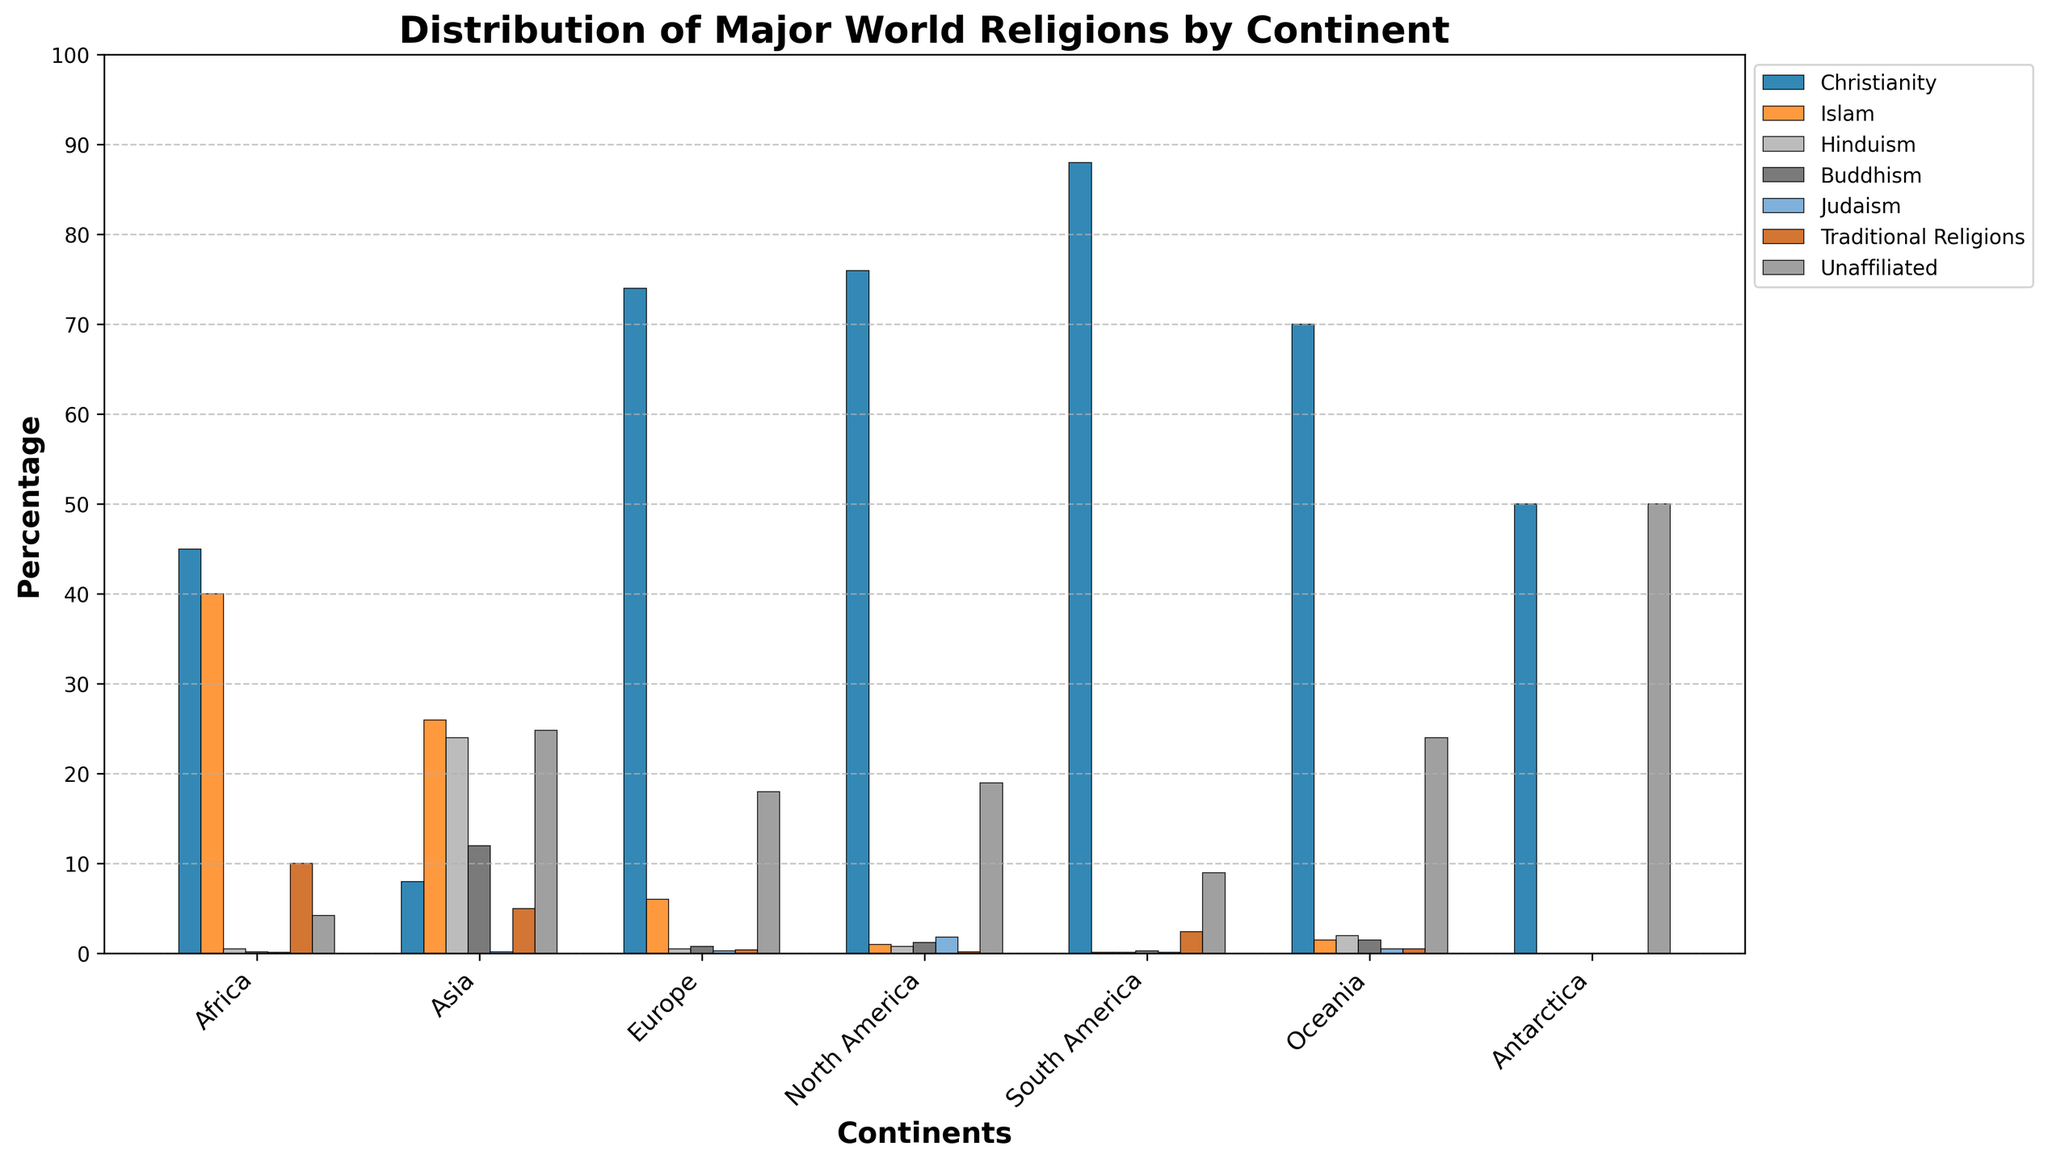What continent has the highest percentage of Christianity? Observing the bar heights for Christianity, the highest bar is over South America.
Answer: South America Which continent has an equal percentage of Unaffiliated and Christianity? By comparing the bars for each religion and continent, Antarctica has equal bars for Unaffiliated and Christianity.
Answer: Antarctica How does the percentage of Islam in Africa compare to that in Asia? The bar for Islam in Africa is at 40, while in Asia it is at 26.
Answer: Higher in Africa Which continent shows the least proportion of Judaism? Observing the bars for Judaism, most continents have some level, but Africa, Asia, and South America each have bars at 0.1 or lower, with South America specifically having the least proportion at 0.1.
Answer: South America What is the combined percentage of Buddhism and Hinduism in Oceania? The bars for Buddhism and Hinduism in Oceania are both at 1.5 and 2, respectively. Summing these values gives 1.5 + 2 = 3.5.
Answer: 3.5 Which religion has the lowest percentage in North America? By comparing the lengths of the bars for each religion in North America, Traditional Religions have the lowest percentage at 0.2.
Answer: Traditional Religions What continent has the most balanced distribution among the seven represented religions? Observing the bar heights, Oceania has a relatively more balanced distribution among the religions compared to other continents.
Answer: Oceania How does the percentage of Traditional Religions in South America compare to that in Africa? For Traditional Religions, the bar for South America stands at 2.4, while for Africa it is at 10.
Answer: Greater in Africa What is the total percentage of all religions in Europe? Summing the percentages of all religions in Europe: 74 (Christianity) + 6 (Islam) + 0.5 (Hinduism) + 0.8 (Buddhism) + 0.3 (Judaism) + 0.4 (Traditional Religions) + 18 (Unaffiliated) = 100.
Answer: 100 Which continent has the greatest disparity between the highest and lowest percentage religion? By observing the highest and lowest bars for each continent, South America has the greatest disparity with 88 (Christianity) and 0.1 (Islam and Hinduism), resulting in a disparity of 88 - 0.1 = 87.9.
Answer: South America 